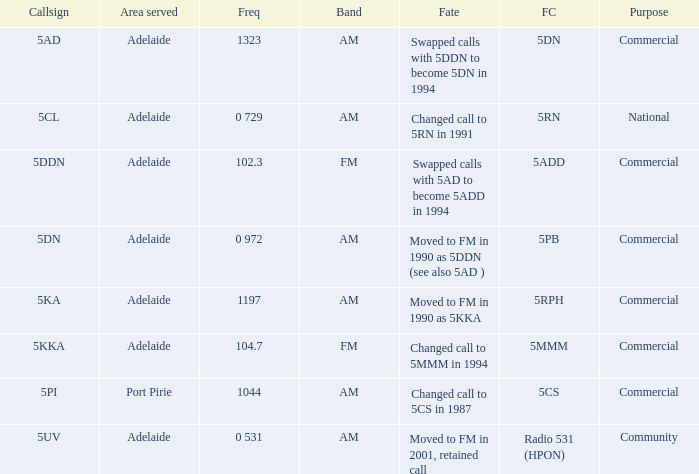What is the purpose for Frequency of 102.3? Commercial. 